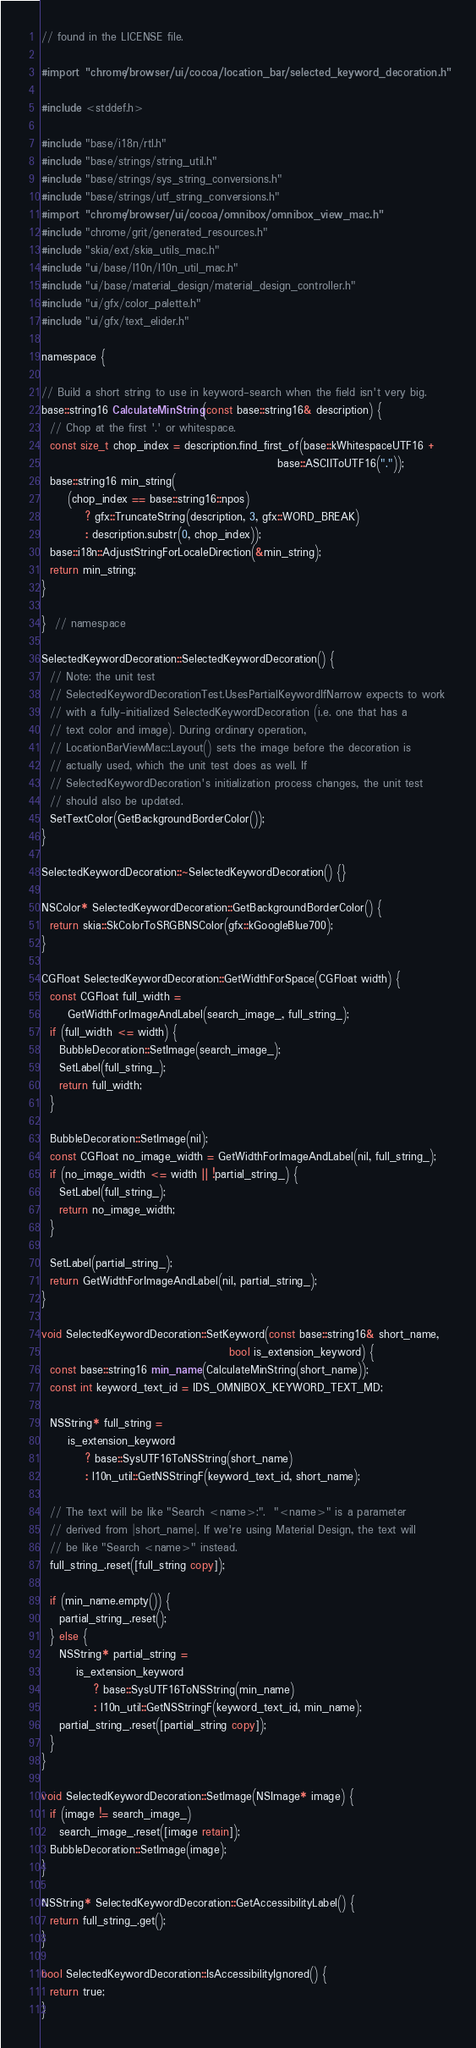<code> <loc_0><loc_0><loc_500><loc_500><_ObjectiveC_>// found in the LICENSE file.

#import "chrome/browser/ui/cocoa/location_bar/selected_keyword_decoration.h"

#include <stddef.h>

#include "base/i18n/rtl.h"
#include "base/strings/string_util.h"
#include "base/strings/sys_string_conversions.h"
#include "base/strings/utf_string_conversions.h"
#import "chrome/browser/ui/cocoa/omnibox/omnibox_view_mac.h"
#include "chrome/grit/generated_resources.h"
#include "skia/ext/skia_utils_mac.h"
#include "ui/base/l10n/l10n_util_mac.h"
#include "ui/base/material_design/material_design_controller.h"
#include "ui/gfx/color_palette.h"
#include "ui/gfx/text_elider.h"

namespace {

// Build a short string to use in keyword-search when the field isn't very big.
base::string16 CalculateMinString(const base::string16& description) {
  // Chop at the first '.' or whitespace.
  const size_t chop_index = description.find_first_of(base::kWhitespaceUTF16 +
                                                      base::ASCIIToUTF16("."));
  base::string16 min_string(
      (chop_index == base::string16::npos)
          ? gfx::TruncateString(description, 3, gfx::WORD_BREAK)
          : description.substr(0, chop_index));
  base::i18n::AdjustStringForLocaleDirection(&min_string);
  return min_string;
}

}  // namespace

SelectedKeywordDecoration::SelectedKeywordDecoration() {
  // Note: the unit test
  // SelectedKeywordDecorationTest.UsesPartialKeywordIfNarrow expects to work
  // with a fully-initialized SelectedKeywordDecoration (i.e. one that has a
  // text color and image). During ordinary operation,
  // LocationBarViewMac::Layout() sets the image before the decoration is
  // actually used, which the unit test does as well. If
  // SelectedKeywordDecoration's initialization process changes, the unit test
  // should also be updated.
  SetTextColor(GetBackgroundBorderColor());
}

SelectedKeywordDecoration::~SelectedKeywordDecoration() {}

NSColor* SelectedKeywordDecoration::GetBackgroundBorderColor() {
  return skia::SkColorToSRGBNSColor(gfx::kGoogleBlue700);
}

CGFloat SelectedKeywordDecoration::GetWidthForSpace(CGFloat width) {
  const CGFloat full_width =
      GetWidthForImageAndLabel(search_image_, full_string_);
  if (full_width <= width) {
    BubbleDecoration::SetImage(search_image_);
    SetLabel(full_string_);
    return full_width;
  }

  BubbleDecoration::SetImage(nil);
  const CGFloat no_image_width = GetWidthForImageAndLabel(nil, full_string_);
  if (no_image_width <= width || !partial_string_) {
    SetLabel(full_string_);
    return no_image_width;
  }

  SetLabel(partial_string_);
  return GetWidthForImageAndLabel(nil, partial_string_);
}

void SelectedKeywordDecoration::SetKeyword(const base::string16& short_name,
                                           bool is_extension_keyword) {
  const base::string16 min_name(CalculateMinString(short_name));
  const int keyword_text_id = IDS_OMNIBOX_KEYWORD_TEXT_MD;

  NSString* full_string =
      is_extension_keyword
          ? base::SysUTF16ToNSString(short_name)
          : l10n_util::GetNSStringF(keyword_text_id, short_name);

  // The text will be like "Search <name>:".  "<name>" is a parameter
  // derived from |short_name|. If we're using Material Design, the text will
  // be like "Search <name>" instead.
  full_string_.reset([full_string copy]);

  if (min_name.empty()) {
    partial_string_.reset();
  } else {
    NSString* partial_string =
        is_extension_keyword
            ? base::SysUTF16ToNSString(min_name)
            : l10n_util::GetNSStringF(keyword_text_id, min_name);
    partial_string_.reset([partial_string copy]);
  }
}

void SelectedKeywordDecoration::SetImage(NSImage* image) {
  if (image != search_image_)
    search_image_.reset([image retain]);
  BubbleDecoration::SetImage(image);
}

NSString* SelectedKeywordDecoration::GetAccessibilityLabel() {
  return full_string_.get();
}

bool SelectedKeywordDecoration::IsAccessibilityIgnored() {
  return true;
}
</code> 